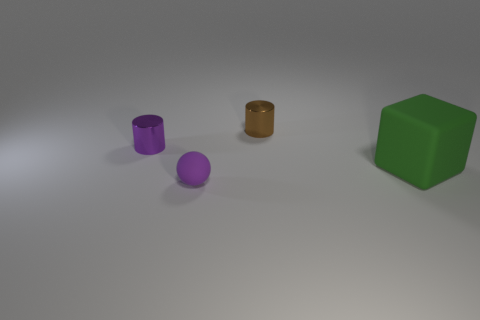Add 3 brown metal cylinders. How many objects exist? 7 Subtract all large green rubber things. Subtract all large blue shiny balls. How many objects are left? 3 Add 2 matte spheres. How many matte spheres are left? 3 Add 3 cyan metal cylinders. How many cyan metal cylinders exist? 3 Subtract 0 yellow cubes. How many objects are left? 4 Subtract all spheres. How many objects are left? 3 